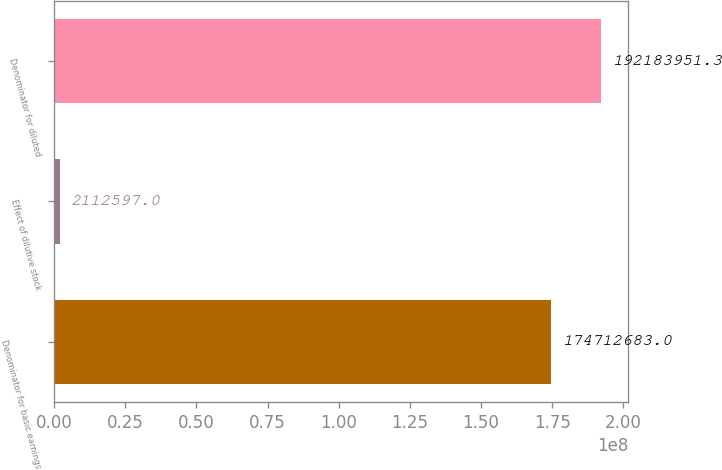Convert chart to OTSL. <chart><loc_0><loc_0><loc_500><loc_500><bar_chart><fcel>Denominator for basic earnings<fcel>Effect of dilutive stock<fcel>Denominator for diluted<nl><fcel>1.74713e+08<fcel>2.1126e+06<fcel>1.92184e+08<nl></chart> 